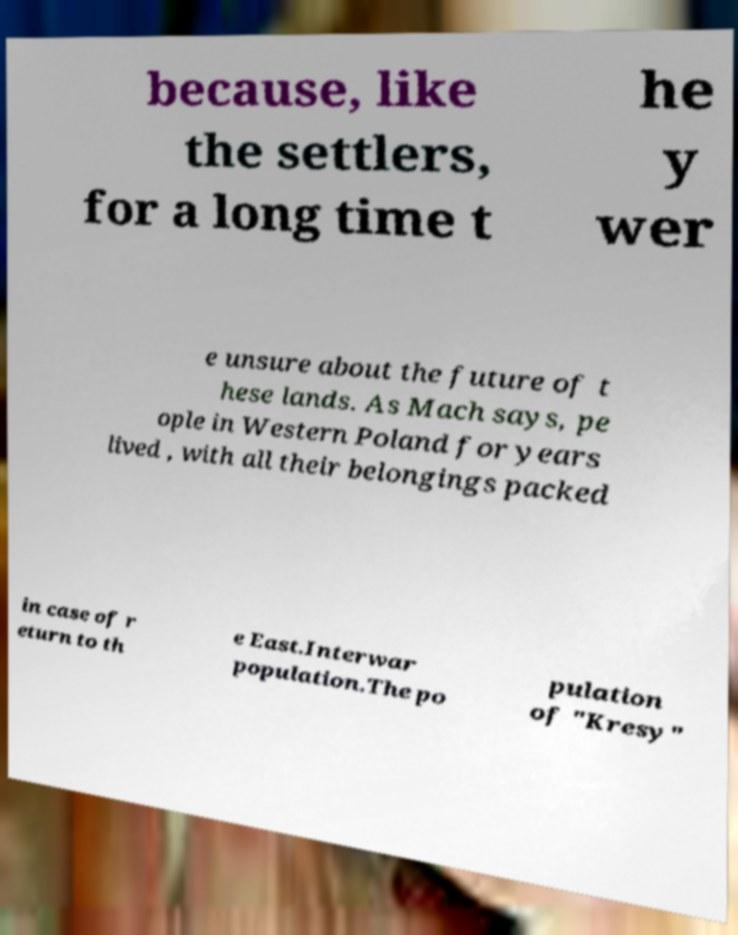Could you extract and type out the text from this image? because, like the settlers, for a long time t he y wer e unsure about the future of t hese lands. As Mach says, pe ople in Western Poland for years lived , with all their belongings packed in case of r eturn to th e East.Interwar population.The po pulation of "Kresy" 